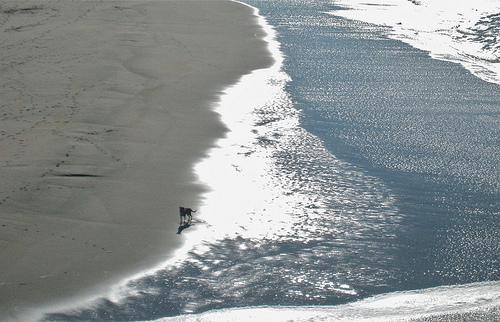Share some insights about the locations and behavior of the pup on the beach. The dog is situated on the beach near the water and appears to be calm and lonely. It stands by itself casting a small shadow, surrounded by wet sand and footprints. Describe the canine seen in the image, as well as the texture and state of the sands. A small dog with a wagging tail, perky ears, and a visible head is standing on the beach. The sand is wet, soft, and flat with several tracks and a dark line visible. Can you tell me about the animal on the beach and the condition of the sand and water? There is a dog on the beach, casting a small shadow and standing alone. The sand is soft, flat, and wet, while the water has ripples, foaming waves, and appears in motion. Identify the animal present in the image and describe its appearance and surroundings. There is a small dog in the image, with a visible head, wagging tail, and perky ears. It is standing on the beach near the water, with a shadow and some footprints around it. Could you provide the primary element in the image and give an explanation of its situation? The main element in the image is a dog that is standing alone on the beach close to the water, casting a small shadow. Mention the principal object and what the water in the image looks like. The main object in the image is a lonely dog standing on the beach. The water is choppy, shimmery, and has white foam with ripples in the rolling sea. Can you comment on the overall atmosphere and appearance of the beach in this image? The beach appears empty and calm, with soft flat sand, a curved coastline, footprints, and a clear boundary where the water meets the sand. Discuss the mood and visual features of the water and beach in the image. The beach has a serene and empty atmosphere, with sand that makes up the coastline and footprints scattered throughout. The water is shimmery with sunlight reflecting on it, clear, and has waves rolling in. What's the dominant feature of the landscape, and what is the condition of the water? The landscape is primarily a beach with wet sand and footprints. The water appears to be somewhat calm, with ripples and foaming waves on the shore. What is the primary entity in the image, including details about the shore and sea? The main entity in the image is an unaccompanied dog standing near the water. The shore contains wet sand and the sea presents foaming waves and ripples in various parts. State the condition of the sand on the beach. wet and flat Describe the coastline in the image. curved with a line where water meets sand Describe the ocean in the image. waves rolling in, white foam, rippling motion, somewhat calm Identify the animal in the image. dog Identify the dark object lying on the sand. black rocks Can you find the little bird perched on one of the black rocks on the beach? There is no indication of any bird present in the image captions, and referring to a specific detail such as "little bird" creates a false impression. Try to spot the seashell hidden under the waves to the left of the dog. There is no mention of any seashell in the image captions, and including a specific direction "left" increases the likelihood of misinformation. Identify the sailboat in the distance, beyond the dark line in the sand. There are no objects in the water other than waves mentioned in the image captions. Adding a specific detail, like "beyond the dark line in the sand," can create confusion. Take note of the approaching storm clouds over the ocean on the right side of the image. There is no mention of any storm or clouds in the captions. The use of an adjective like "approaching" and a specific direction "right" adds to the misleading nature of the instruction. Choose an accurate description for the sand in the image: (a) dry, rocky sand (b) soft, flat, wet sand (c) muddy sand (d) pebbly sand b State the type of water at the shore. shimmery, motioning, and somewhat calm What is the color of the water in motion? white State the contents of the image regarding the sand. wet, flat beach sand with footprints and black rocks What kind of scene is portrayed in the image? a serene and empty beach scene Does the dog cast any shadow in the image? If so, describe the shadow. yes, the dog is casting a small shadow Detect any notable expressions of the dog. no discernible facial expressions What is happening to the wave in the sand? forming a c-shape and dying Interpret the texture and state of the water in the image. ripples, shimmery, choppy, and calming What is the state of the water near the shore? shimmery and calm with ripples Notice how the sun's reflection creates a brilliant rainbow in the water close to the shoreline. The image captions mention sunlight reflecting on the water, but there is no mention of a rainbow. Adding a vivid adjective like "brilliant" makes it more misleading. What does the dog's tail indicate about its mood? It's unclear, as the tail is wagging but not noticeably expressive Identify and describe the pattern in the sand. several tracks and footprints on the wet sand Can you find the child's sandcastle close to the footprints on the beach? No structures or buildings are mentioned in the image captions. Introducing an unrelated subject, such as "sandcastle" and linking it to an existing detail, like "footprints," can lead to confusion. Describe the overall scenery depicted in the image. an empty beach with a lonely dog near the ocean shoreline Capture the scene in a haiku. lonely dog on beach, 